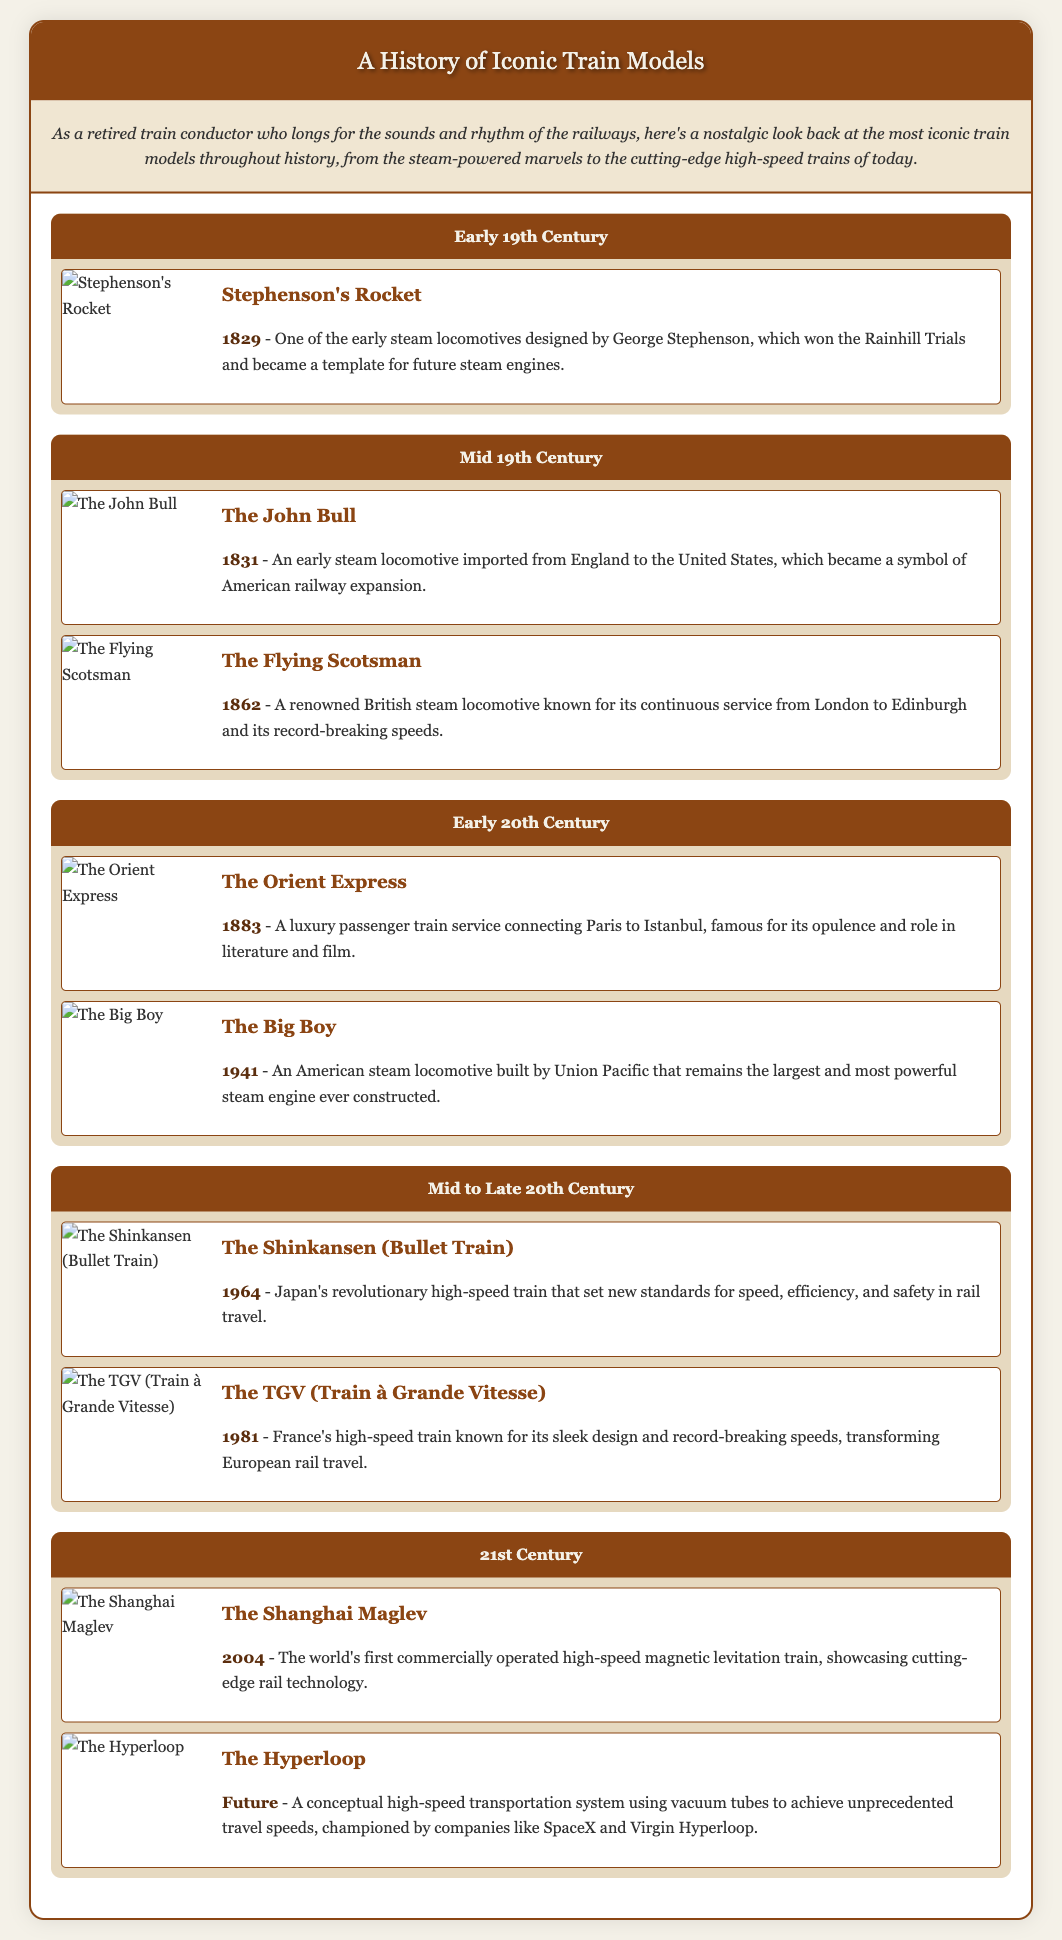What year was Stephenson's Rocket introduced? The document states that Stephenson's Rocket was introduced in 1829.
Answer: 1829 Which train is known for its opulence and role in literature and film? The Orient Express is highlighted in the document for its luxury and cultural significance.
Answer: The Orient Express What is the name of the largest and most powerful steam engine ever constructed? The document identifies The Big Boy as the largest and most powerful steam engine.
Answer: The Big Boy In what year did the Shinkansen (Bullet Train) begin operation? According to the document, the Shinkansen started in 1964.
Answer: 1964 How many iconic train models are listed in the timeline? The document presents a total of 10 iconic train models throughout the timeline.
Answer: 10 What is the future conceptual train mentioned in the document? The document refers to the Hyperloop as the future conceptual high-speed transportation system.
Answer: The Hyperloop Which train service is recognized for its record-breaking speeds from London to Edinburgh? The Flying Scotsman is noted in the document for its continuous service and record speeds.
Answer: The Flying Scotsman What innovative technology does the Shanghai Maglev utilize? The document specifies that the Shanghai Maglev uses magnetic levitation technology.
Answer: Magnetic levitation 